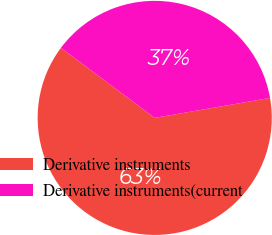Convert chart. <chart><loc_0><loc_0><loc_500><loc_500><pie_chart><fcel>Derivative instruments<fcel>Derivative instruments(current<nl><fcel>62.94%<fcel>37.06%<nl></chart> 